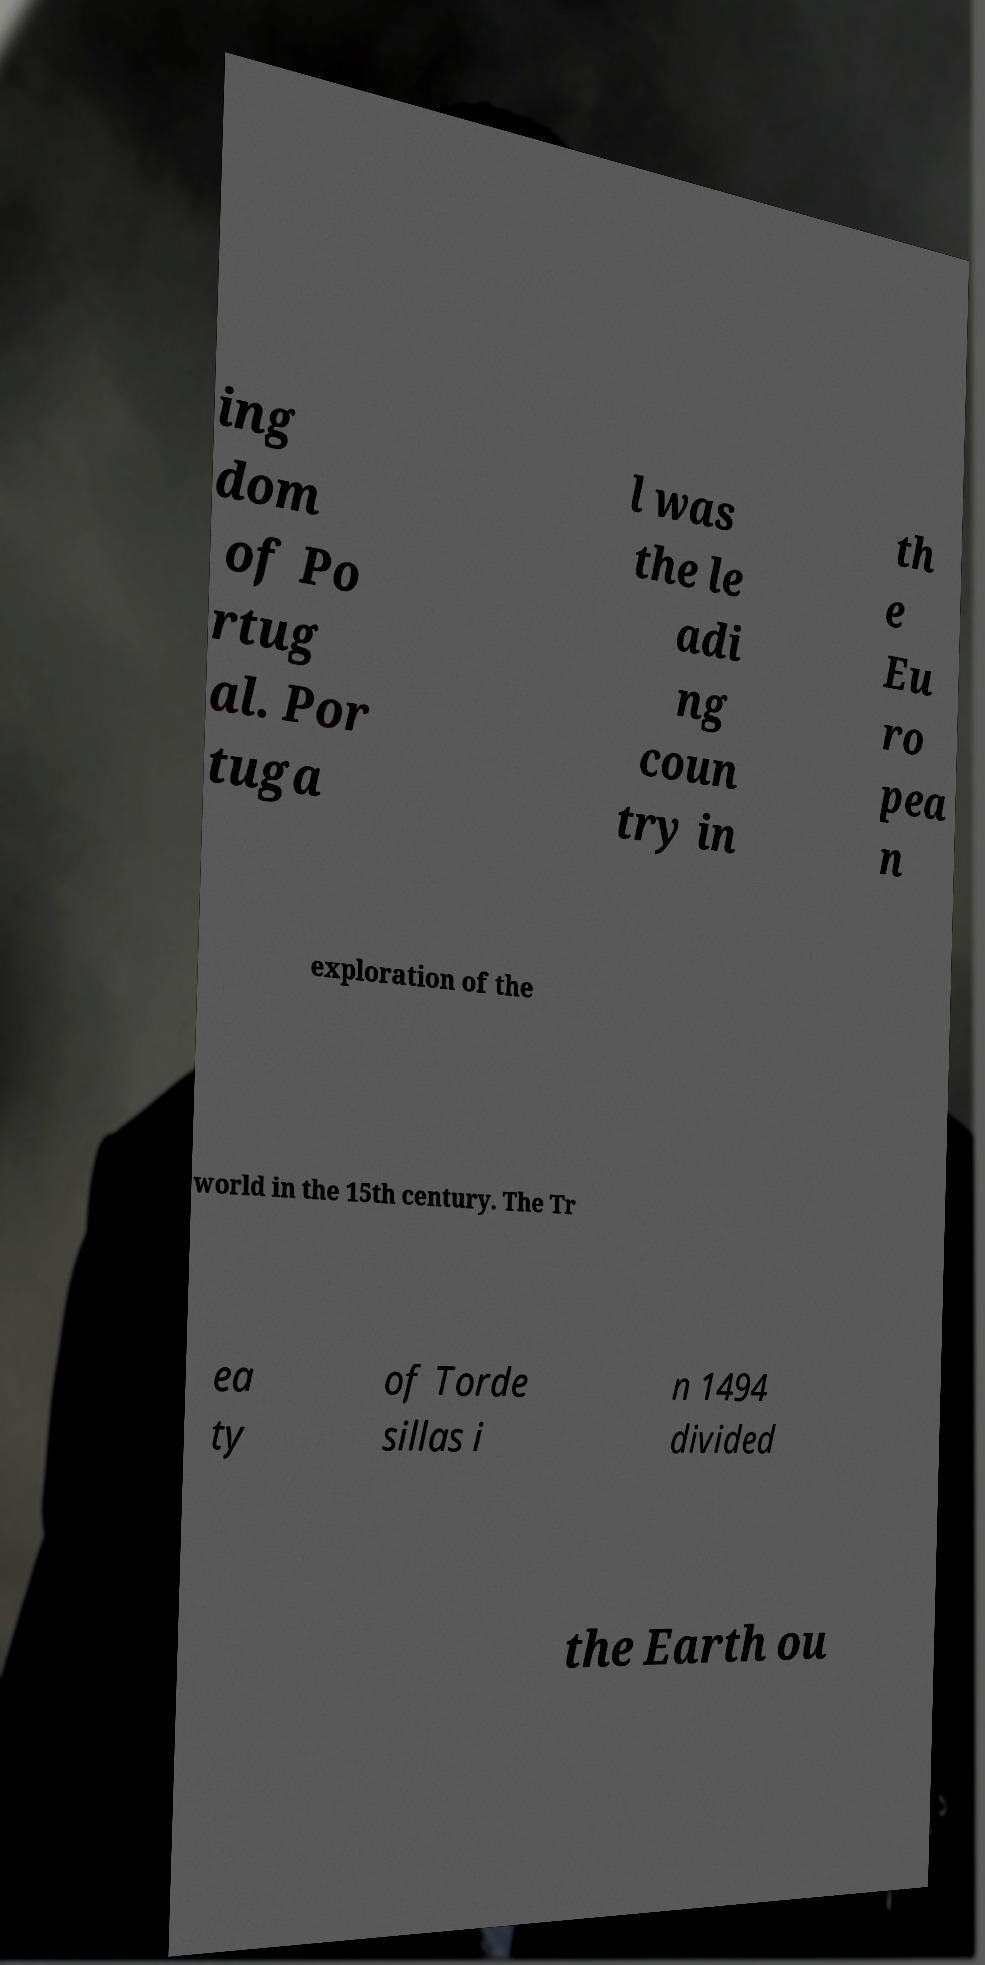Please identify and transcribe the text found in this image. ing dom of Po rtug al. Por tuga l was the le adi ng coun try in th e Eu ro pea n exploration of the world in the 15th century. The Tr ea ty of Torde sillas i n 1494 divided the Earth ou 